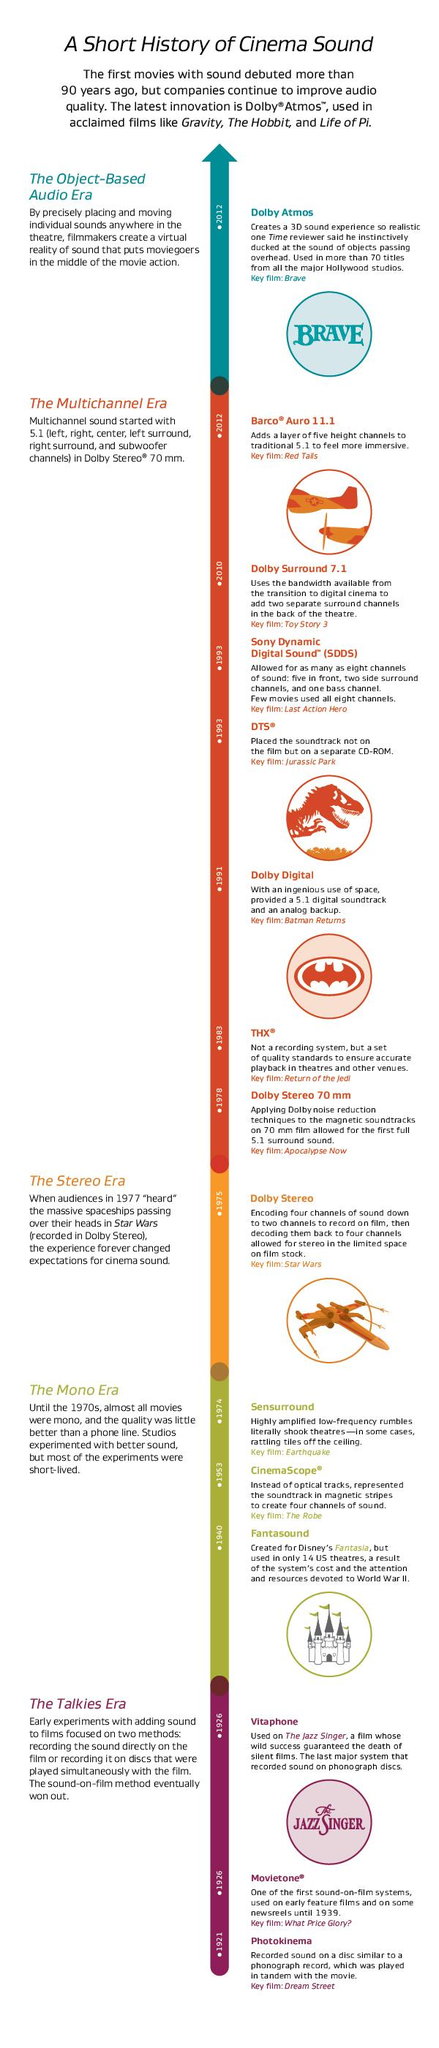Point out several critical features in this image. The Fantasound audio system was not used first, as it was developed after the Movietone system. The sound system known as Sensurround was highly amplified and capable of causing tiles to shake loose from ceilings. The Mono era came before the Stereo era. DTS was the first audio system to be introduced, followed by SDDS. The Multichannel Era had the most number of audio systems. 